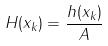<formula> <loc_0><loc_0><loc_500><loc_500>H ( x _ { k } ) = \frac { h ( x _ { k } ) } { A }</formula> 